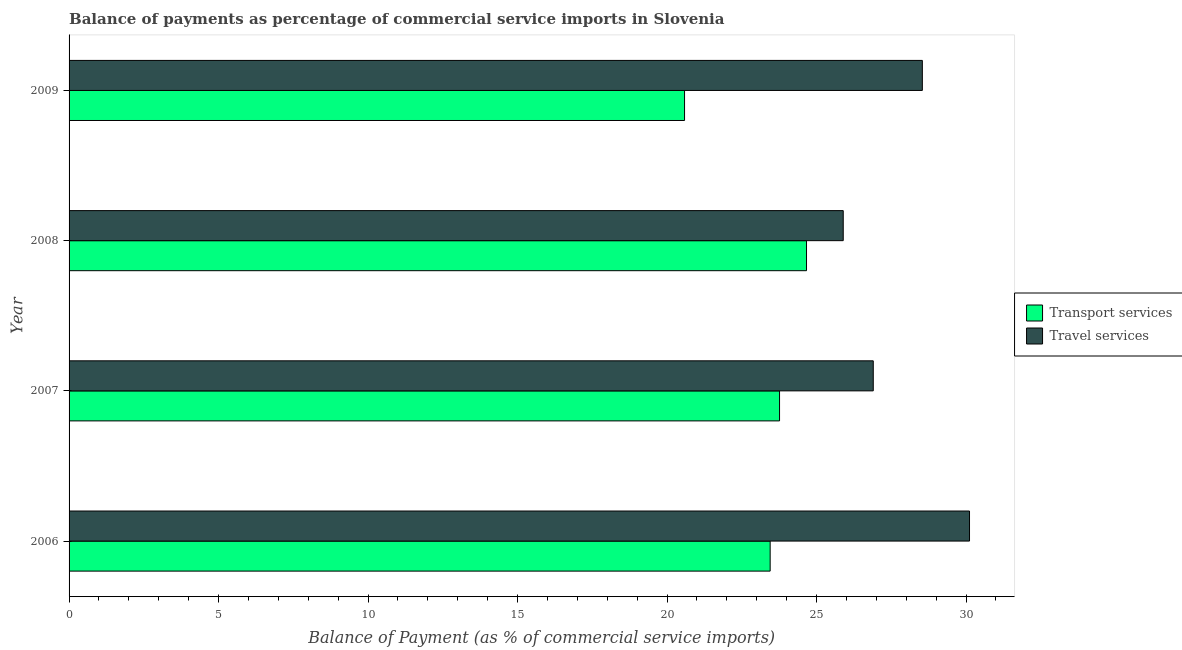How many groups of bars are there?
Ensure brevity in your answer.  4. Are the number of bars per tick equal to the number of legend labels?
Ensure brevity in your answer.  Yes. Are the number of bars on each tick of the Y-axis equal?
Keep it short and to the point. Yes. How many bars are there on the 4th tick from the bottom?
Keep it short and to the point. 2. In how many cases, is the number of bars for a given year not equal to the number of legend labels?
Keep it short and to the point. 0. What is the balance of payments of travel services in 2007?
Give a very brief answer. 26.9. Across all years, what is the maximum balance of payments of transport services?
Keep it short and to the point. 24.66. Across all years, what is the minimum balance of payments of transport services?
Provide a succinct answer. 20.58. In which year was the balance of payments of travel services maximum?
Your response must be concise. 2006. What is the total balance of payments of transport services in the graph?
Offer a terse response. 92.46. What is the difference between the balance of payments of travel services in 2006 and that in 2007?
Provide a succinct answer. 3.22. What is the difference between the balance of payments of travel services in 2008 and the balance of payments of transport services in 2007?
Offer a terse response. 2.13. What is the average balance of payments of transport services per year?
Provide a succinct answer. 23.11. In the year 2007, what is the difference between the balance of payments of travel services and balance of payments of transport services?
Ensure brevity in your answer.  3.13. In how many years, is the balance of payments of transport services greater than 6 %?
Make the answer very short. 4. What is the ratio of the balance of payments of travel services in 2006 to that in 2008?
Your response must be concise. 1.16. Is the difference between the balance of payments of transport services in 2006 and 2008 greater than the difference between the balance of payments of travel services in 2006 and 2008?
Your answer should be compact. No. What is the difference between the highest and the second highest balance of payments of travel services?
Offer a very short reply. 1.58. What is the difference between the highest and the lowest balance of payments of travel services?
Your response must be concise. 4.22. What does the 2nd bar from the top in 2008 represents?
Offer a terse response. Transport services. What does the 1st bar from the bottom in 2009 represents?
Provide a succinct answer. Transport services. How many bars are there?
Your answer should be very brief. 8. Are all the bars in the graph horizontal?
Your answer should be very brief. Yes. What is the difference between two consecutive major ticks on the X-axis?
Keep it short and to the point. 5. Does the graph contain any zero values?
Offer a terse response. No. Does the graph contain grids?
Keep it short and to the point. No. Where does the legend appear in the graph?
Give a very brief answer. Center right. What is the title of the graph?
Your response must be concise. Balance of payments as percentage of commercial service imports in Slovenia. What is the label or title of the X-axis?
Ensure brevity in your answer.  Balance of Payment (as % of commercial service imports). What is the Balance of Payment (as % of commercial service imports) in Transport services in 2006?
Make the answer very short. 23.45. What is the Balance of Payment (as % of commercial service imports) in Travel services in 2006?
Ensure brevity in your answer.  30.11. What is the Balance of Payment (as % of commercial service imports) of Transport services in 2007?
Offer a very short reply. 23.76. What is the Balance of Payment (as % of commercial service imports) of Travel services in 2007?
Your answer should be compact. 26.9. What is the Balance of Payment (as % of commercial service imports) of Transport services in 2008?
Provide a succinct answer. 24.66. What is the Balance of Payment (as % of commercial service imports) of Travel services in 2008?
Your answer should be very brief. 25.89. What is the Balance of Payment (as % of commercial service imports) in Transport services in 2009?
Ensure brevity in your answer.  20.58. What is the Balance of Payment (as % of commercial service imports) in Travel services in 2009?
Your response must be concise. 28.54. Across all years, what is the maximum Balance of Payment (as % of commercial service imports) of Transport services?
Ensure brevity in your answer.  24.66. Across all years, what is the maximum Balance of Payment (as % of commercial service imports) of Travel services?
Your response must be concise. 30.11. Across all years, what is the minimum Balance of Payment (as % of commercial service imports) in Transport services?
Provide a succinct answer. 20.58. Across all years, what is the minimum Balance of Payment (as % of commercial service imports) in Travel services?
Offer a very short reply. 25.89. What is the total Balance of Payment (as % of commercial service imports) of Transport services in the graph?
Provide a succinct answer. 92.46. What is the total Balance of Payment (as % of commercial service imports) of Travel services in the graph?
Your answer should be compact. 111.44. What is the difference between the Balance of Payment (as % of commercial service imports) in Transport services in 2006 and that in 2007?
Provide a succinct answer. -0.31. What is the difference between the Balance of Payment (as % of commercial service imports) in Travel services in 2006 and that in 2007?
Provide a short and direct response. 3.22. What is the difference between the Balance of Payment (as % of commercial service imports) in Transport services in 2006 and that in 2008?
Your response must be concise. -1.22. What is the difference between the Balance of Payment (as % of commercial service imports) of Travel services in 2006 and that in 2008?
Keep it short and to the point. 4.22. What is the difference between the Balance of Payment (as % of commercial service imports) in Transport services in 2006 and that in 2009?
Your answer should be compact. 2.86. What is the difference between the Balance of Payment (as % of commercial service imports) of Travel services in 2006 and that in 2009?
Ensure brevity in your answer.  1.58. What is the difference between the Balance of Payment (as % of commercial service imports) in Transport services in 2007 and that in 2008?
Make the answer very short. -0.9. What is the difference between the Balance of Payment (as % of commercial service imports) of Travel services in 2007 and that in 2008?
Your answer should be compact. 1. What is the difference between the Balance of Payment (as % of commercial service imports) in Transport services in 2007 and that in 2009?
Provide a succinct answer. 3.18. What is the difference between the Balance of Payment (as % of commercial service imports) in Travel services in 2007 and that in 2009?
Make the answer very short. -1.64. What is the difference between the Balance of Payment (as % of commercial service imports) in Transport services in 2008 and that in 2009?
Provide a short and direct response. 4.08. What is the difference between the Balance of Payment (as % of commercial service imports) in Travel services in 2008 and that in 2009?
Your answer should be very brief. -2.65. What is the difference between the Balance of Payment (as % of commercial service imports) in Transport services in 2006 and the Balance of Payment (as % of commercial service imports) in Travel services in 2007?
Your answer should be compact. -3.45. What is the difference between the Balance of Payment (as % of commercial service imports) in Transport services in 2006 and the Balance of Payment (as % of commercial service imports) in Travel services in 2008?
Offer a terse response. -2.44. What is the difference between the Balance of Payment (as % of commercial service imports) of Transport services in 2006 and the Balance of Payment (as % of commercial service imports) of Travel services in 2009?
Give a very brief answer. -5.09. What is the difference between the Balance of Payment (as % of commercial service imports) in Transport services in 2007 and the Balance of Payment (as % of commercial service imports) in Travel services in 2008?
Offer a very short reply. -2.13. What is the difference between the Balance of Payment (as % of commercial service imports) of Transport services in 2007 and the Balance of Payment (as % of commercial service imports) of Travel services in 2009?
Offer a very short reply. -4.78. What is the difference between the Balance of Payment (as % of commercial service imports) of Transport services in 2008 and the Balance of Payment (as % of commercial service imports) of Travel services in 2009?
Your response must be concise. -3.87. What is the average Balance of Payment (as % of commercial service imports) of Transport services per year?
Provide a short and direct response. 23.11. What is the average Balance of Payment (as % of commercial service imports) in Travel services per year?
Offer a very short reply. 27.86. In the year 2006, what is the difference between the Balance of Payment (as % of commercial service imports) in Transport services and Balance of Payment (as % of commercial service imports) in Travel services?
Your answer should be very brief. -6.67. In the year 2007, what is the difference between the Balance of Payment (as % of commercial service imports) in Transport services and Balance of Payment (as % of commercial service imports) in Travel services?
Your answer should be compact. -3.13. In the year 2008, what is the difference between the Balance of Payment (as % of commercial service imports) in Transport services and Balance of Payment (as % of commercial service imports) in Travel services?
Keep it short and to the point. -1.23. In the year 2009, what is the difference between the Balance of Payment (as % of commercial service imports) in Transport services and Balance of Payment (as % of commercial service imports) in Travel services?
Your response must be concise. -7.95. What is the ratio of the Balance of Payment (as % of commercial service imports) of Travel services in 2006 to that in 2007?
Your answer should be compact. 1.12. What is the ratio of the Balance of Payment (as % of commercial service imports) of Transport services in 2006 to that in 2008?
Your answer should be very brief. 0.95. What is the ratio of the Balance of Payment (as % of commercial service imports) in Travel services in 2006 to that in 2008?
Provide a short and direct response. 1.16. What is the ratio of the Balance of Payment (as % of commercial service imports) of Transport services in 2006 to that in 2009?
Make the answer very short. 1.14. What is the ratio of the Balance of Payment (as % of commercial service imports) in Travel services in 2006 to that in 2009?
Provide a short and direct response. 1.06. What is the ratio of the Balance of Payment (as % of commercial service imports) in Transport services in 2007 to that in 2008?
Ensure brevity in your answer.  0.96. What is the ratio of the Balance of Payment (as % of commercial service imports) in Travel services in 2007 to that in 2008?
Provide a succinct answer. 1.04. What is the ratio of the Balance of Payment (as % of commercial service imports) in Transport services in 2007 to that in 2009?
Your answer should be compact. 1.15. What is the ratio of the Balance of Payment (as % of commercial service imports) of Travel services in 2007 to that in 2009?
Your answer should be compact. 0.94. What is the ratio of the Balance of Payment (as % of commercial service imports) in Transport services in 2008 to that in 2009?
Your response must be concise. 1.2. What is the ratio of the Balance of Payment (as % of commercial service imports) in Travel services in 2008 to that in 2009?
Your response must be concise. 0.91. What is the difference between the highest and the second highest Balance of Payment (as % of commercial service imports) in Transport services?
Provide a short and direct response. 0.9. What is the difference between the highest and the second highest Balance of Payment (as % of commercial service imports) of Travel services?
Keep it short and to the point. 1.58. What is the difference between the highest and the lowest Balance of Payment (as % of commercial service imports) in Transport services?
Offer a terse response. 4.08. What is the difference between the highest and the lowest Balance of Payment (as % of commercial service imports) in Travel services?
Offer a terse response. 4.22. 